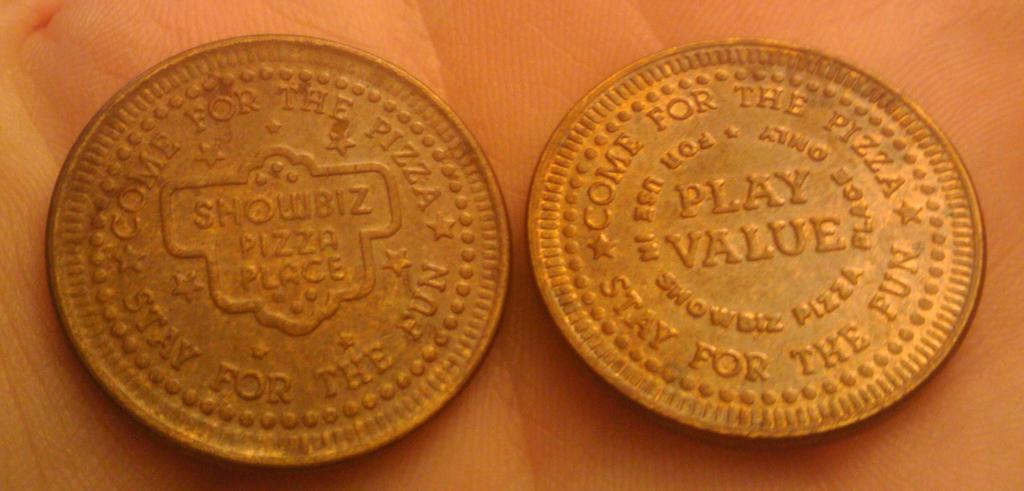What's the name of the pizza place?
Make the answer very short. Showbiz pizza place. What should you come for?
Your answer should be compact. Pizza. 